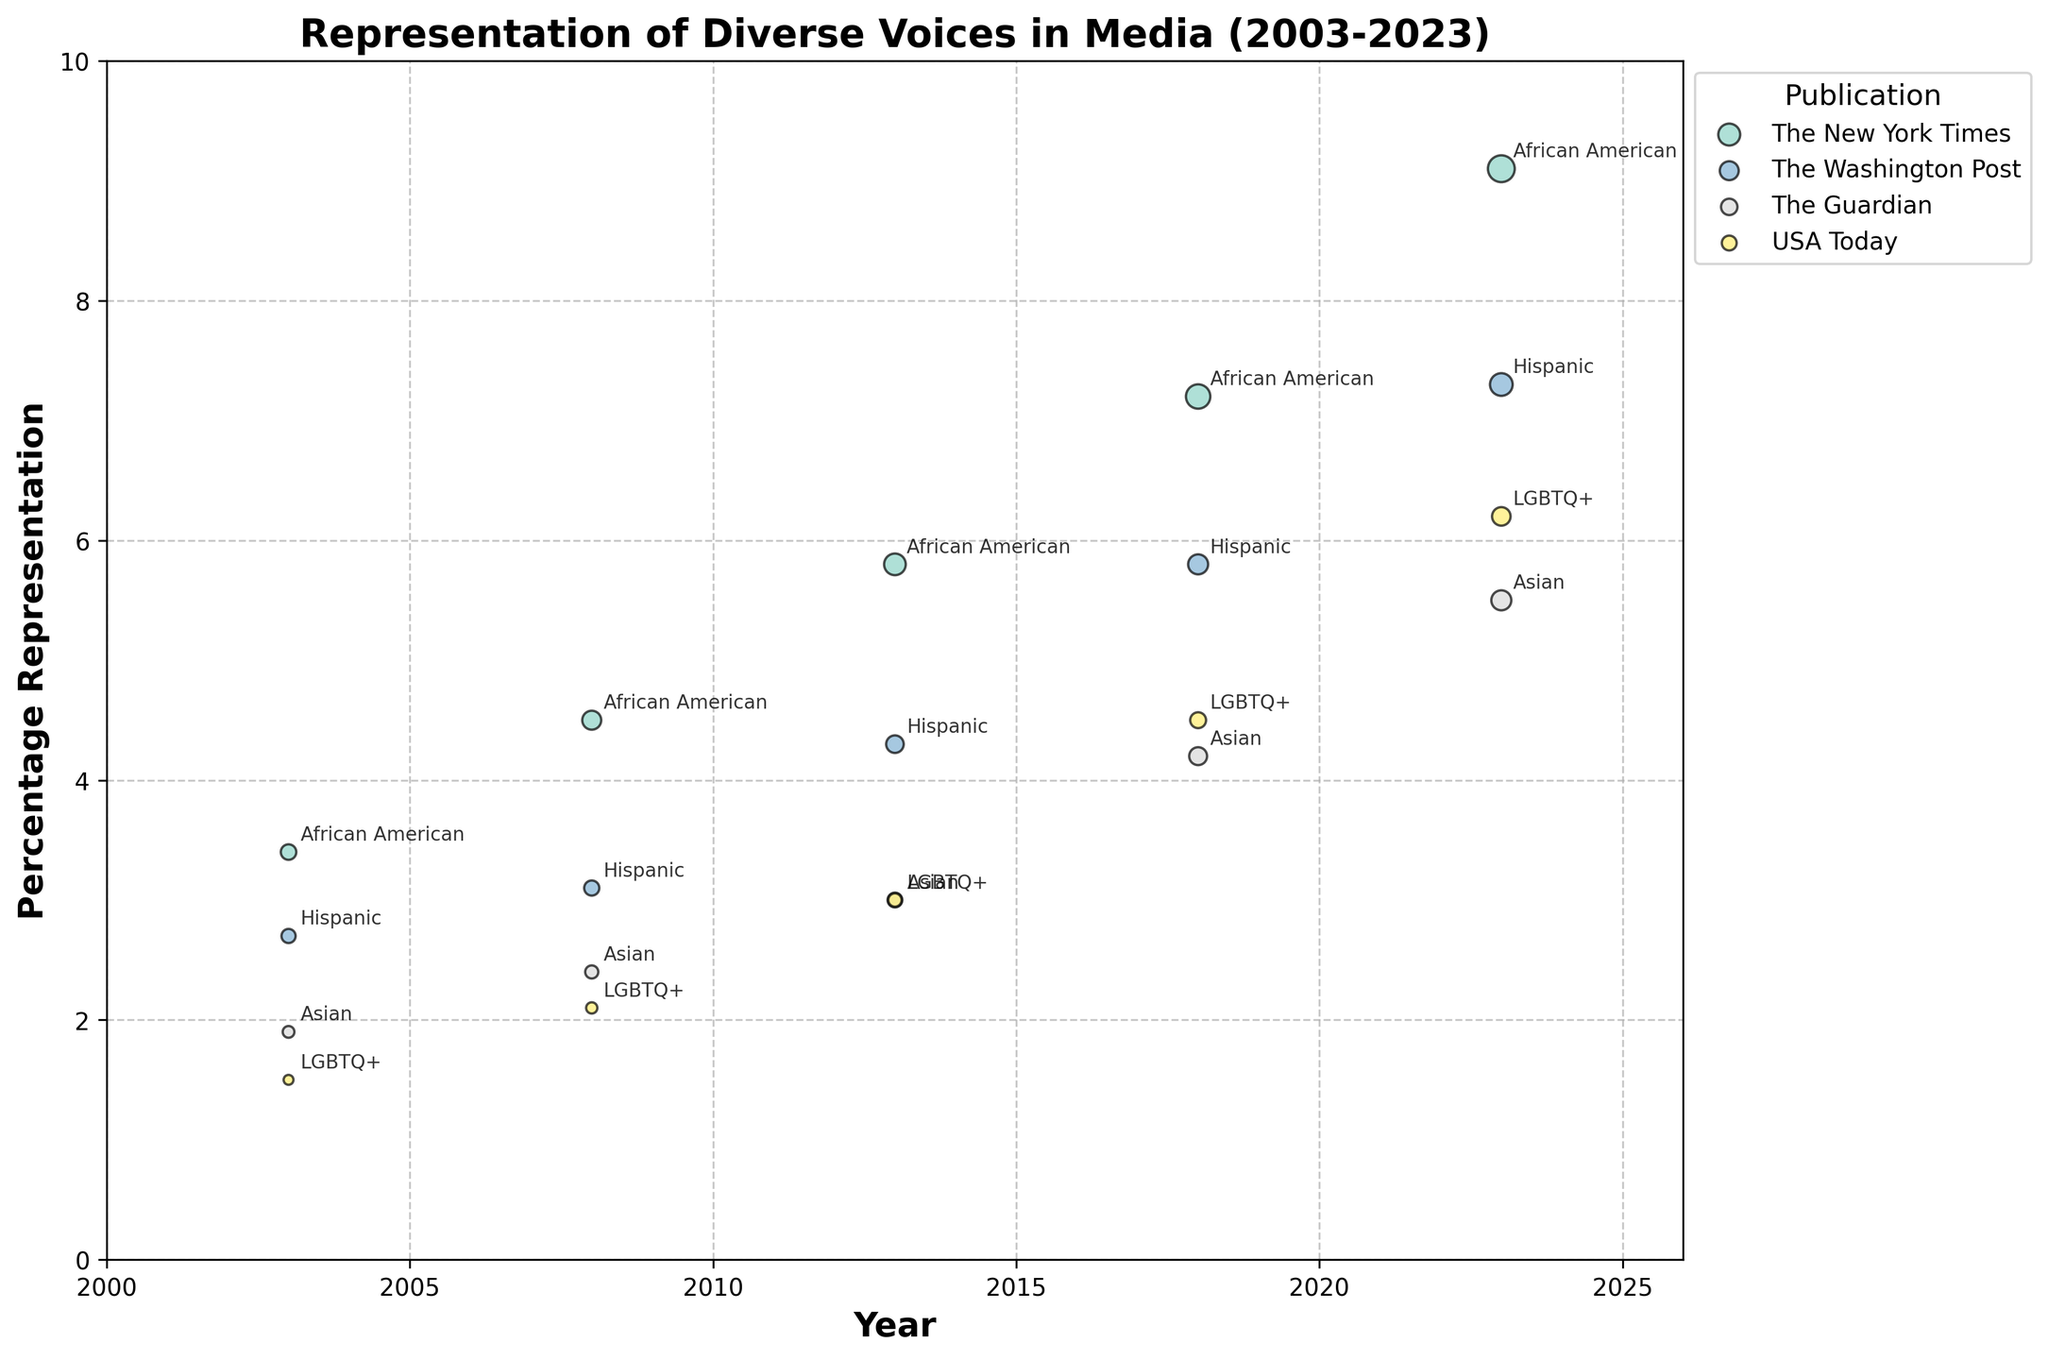What is the title of the figure? The title of a figure is typically displayed at the top in a bold font. In this plot, it reads "Representation of Diverse Voices in Media (2003-2023)"
Answer: Representation of Diverse Voices in Media (2003-2023) What does the x-axis represent? The labeling along the x-axis indicates the variable it represents. Here, it is marked with "Year"
Answer: Year Which publication has the highest percentage representation for African Americans in 2023? To determine this, look for the label “African American” in 2023 on the plot and find the highest point along the y-axis. The corresponding bubble is for "The New York Times" with 9.1%
Answer: The New York Times How many total articles did The Washington Post publish about the Hispanic minority group in 2008 and 2018 combined? Identify the number of articles for The Washington Post for Hispanic in 2008 (200) and 2018 (350), then sum these values. 200 + 350 = 550
Answer: 550 Which minority group saw the lowest percentage representation in 2003, and what was the percentage? By identifying the lowest bubble along the y-axis in 2003, we see it corresponds to "LGBTQ+" with a percentage of 1.5%
Answer: LGBTQ+, 1.5% How did the percentage representation of Asian minority groups change for The Guardian from 2003 to 2023? Note the percentages for The Guardian in 2003 (1.9) and 2023 (5.5). Calculate the difference. 5.5 - 1.9 = 3.6
Answer: Increased by 3.6% Compare the percentage representation of LGBTQ+ in 2018 to 2023 for USA Today. Which year had the higher percentage? Find the y-values for USA Today in 2018 (4.5) and 2023 (6.2), then compare them. The percentage is higher in 2023 (6.2 > 4.5)
Answer: 2023 Which publication shows the most substantial increase in the number of articles addressing minority groups from 2003 to 2023? Check each publication by examining the number of articles in 2003 and 2023, then calculate the differences. The New York Times has the increase from 210 to 630, which is greater than other publications
Answer: The New York Times In 2013, which minority group has equal representation percentages in USA Today and The Guardian? Compare the y-values for each minority group in 2013 for both The Guardian and USA Today. Both show 3.0% for the Asian group
Answer: Asian How does the average percentage representation of Hispanic minority groups in The Washington Post over the 20-year span compare to the LGBTQ+ representation in USA Today in 2023? First compute the average for Hispanic in The Washington Post over the years (2003: 2.7, 2008: 3.1, 2013: 4.3, 2018: 5.8, 2023: 7.3); sum = 23.2, average = 23.2/5 = 4.64%. Compare this to the 2023 LGBTQ+ representation in USA Today, which is 6.2%. Hence, the average Hispanic representation is less than the LGBTQ+ representation in 2023
Answer: Less 